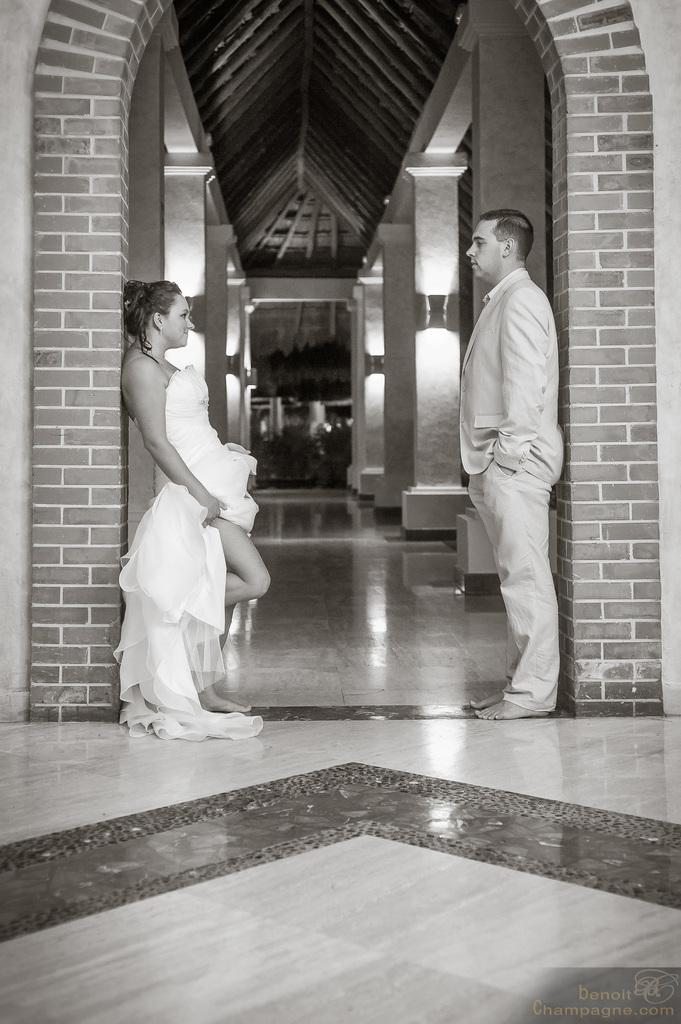Who are the people in the image? There is a lady and a guy in the image. What are they doing in the image? They are standing in between an arch. What can be seen under their feet in the image? The floor is visible in the image. What is visible in the background of the image? There are lights and bricks on the wall in the background of the image. What is the chance of winning a marble in the image? There is no mention of a marble or any game in the image, so it's not possible to determine the chance of winning one. 